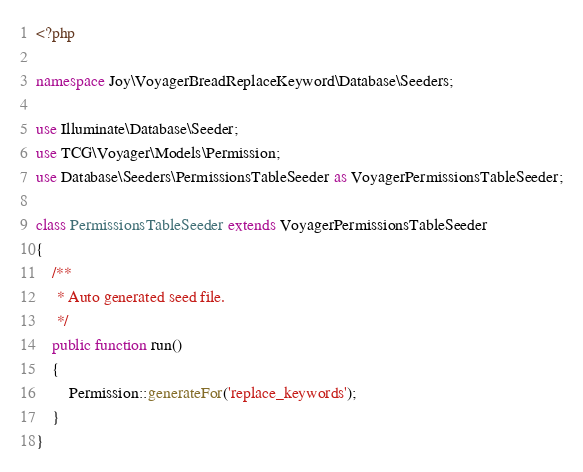Convert code to text. <code><loc_0><loc_0><loc_500><loc_500><_PHP_><?php

namespace Joy\VoyagerBreadReplaceKeyword\Database\Seeders;

use Illuminate\Database\Seeder;
use TCG\Voyager\Models\Permission;
use Database\Seeders\PermissionsTableSeeder as VoyagerPermissionsTableSeeder;

class PermissionsTableSeeder extends VoyagerPermissionsTableSeeder
{
    /**
     * Auto generated seed file.
     */
    public function run()
    {
        Permission::generateFor('replace_keywords');
    }
}
</code> 